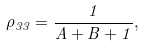<formula> <loc_0><loc_0><loc_500><loc_500>\rho _ { 3 3 } = \frac { 1 } { A + B + 1 } ,</formula> 